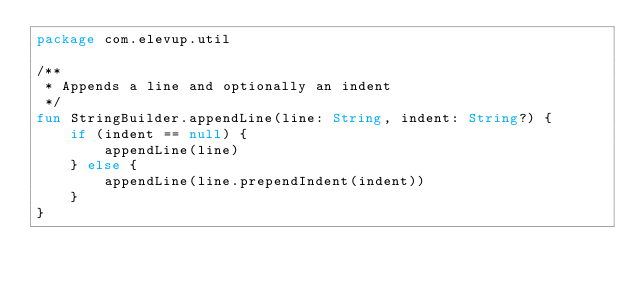<code> <loc_0><loc_0><loc_500><loc_500><_Kotlin_>package com.elevup.util

/**
 * Appends a line and optionally an indent
 */
fun StringBuilder.appendLine(line: String, indent: String?) {
    if (indent == null) {
        appendLine(line)
    } else {
        appendLine(line.prependIndent(indent))
    }
}
</code> 